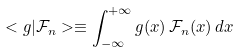<formula> <loc_0><loc_0><loc_500><loc_500>< g | \mathcal { F } _ { n } > \equiv \int _ { - \infty } ^ { + \infty } g ( x ) \, \mathcal { F } _ { n } ( x ) \, d x</formula> 